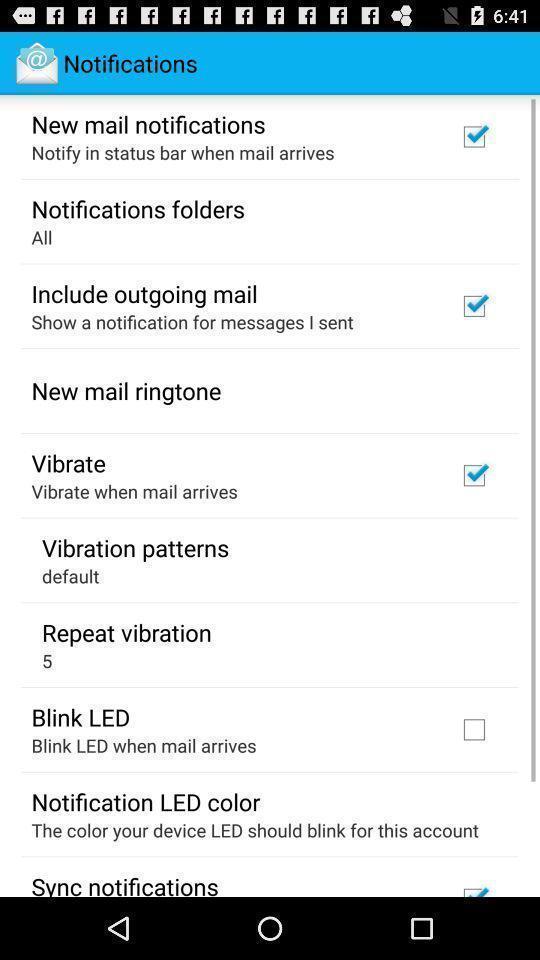Tell me about the visual elements in this screen capture. Screen showing notifications. 